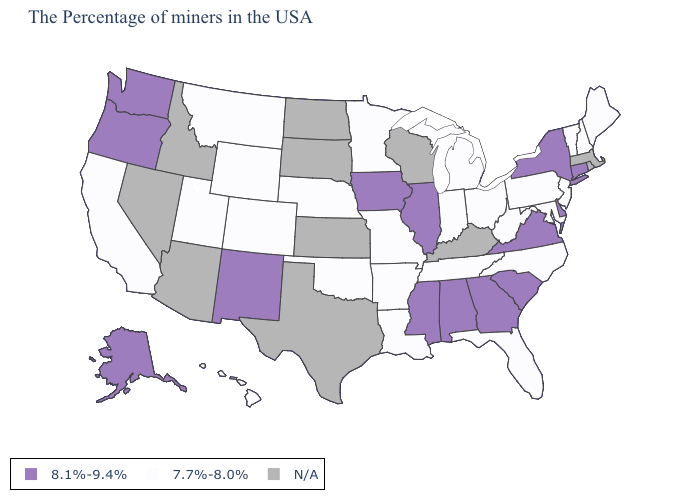Name the states that have a value in the range 8.1%-9.4%?
Quick response, please. Connecticut, New York, Delaware, Virginia, South Carolina, Georgia, Alabama, Illinois, Mississippi, Iowa, New Mexico, Washington, Oregon, Alaska. Name the states that have a value in the range 7.7%-8.0%?
Write a very short answer. Maine, New Hampshire, Vermont, New Jersey, Maryland, Pennsylvania, North Carolina, West Virginia, Ohio, Florida, Michigan, Indiana, Tennessee, Louisiana, Missouri, Arkansas, Minnesota, Nebraska, Oklahoma, Wyoming, Colorado, Utah, Montana, California, Hawaii. What is the value of New Jersey?
Give a very brief answer. 7.7%-8.0%. Does Indiana have the highest value in the MidWest?
Short answer required. No. What is the highest value in states that border Colorado?
Short answer required. 8.1%-9.4%. Does Tennessee have the lowest value in the South?
Short answer required. Yes. What is the value of Vermont?
Write a very short answer. 7.7%-8.0%. What is the highest value in the USA?
Short answer required. 8.1%-9.4%. Name the states that have a value in the range 7.7%-8.0%?
Concise answer only. Maine, New Hampshire, Vermont, New Jersey, Maryland, Pennsylvania, North Carolina, West Virginia, Ohio, Florida, Michigan, Indiana, Tennessee, Louisiana, Missouri, Arkansas, Minnesota, Nebraska, Oklahoma, Wyoming, Colorado, Utah, Montana, California, Hawaii. Among the states that border Arizona , does New Mexico have the highest value?
Write a very short answer. Yes. Does the first symbol in the legend represent the smallest category?
Write a very short answer. No. Name the states that have a value in the range N/A?
Short answer required. Massachusetts, Rhode Island, Kentucky, Wisconsin, Kansas, Texas, South Dakota, North Dakota, Arizona, Idaho, Nevada. Name the states that have a value in the range 7.7%-8.0%?
Keep it brief. Maine, New Hampshire, Vermont, New Jersey, Maryland, Pennsylvania, North Carolina, West Virginia, Ohio, Florida, Michigan, Indiana, Tennessee, Louisiana, Missouri, Arkansas, Minnesota, Nebraska, Oklahoma, Wyoming, Colorado, Utah, Montana, California, Hawaii. Name the states that have a value in the range 8.1%-9.4%?
Write a very short answer. Connecticut, New York, Delaware, Virginia, South Carolina, Georgia, Alabama, Illinois, Mississippi, Iowa, New Mexico, Washington, Oregon, Alaska. 